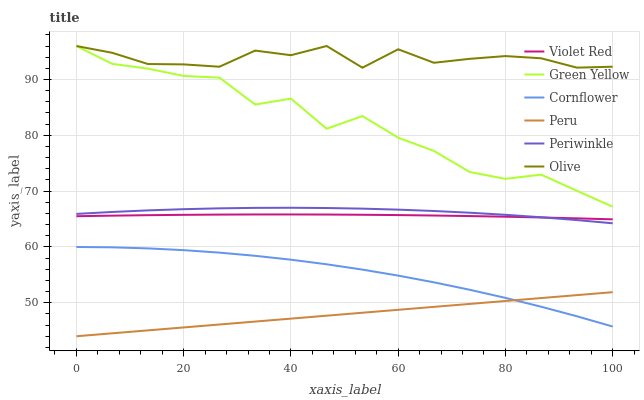Does Peru have the minimum area under the curve?
Answer yes or no. Yes. Does Olive have the maximum area under the curve?
Answer yes or no. Yes. Does Violet Red have the minimum area under the curve?
Answer yes or no. No. Does Violet Red have the maximum area under the curve?
Answer yes or no. No. Is Peru the smoothest?
Answer yes or no. Yes. Is Green Yellow the roughest?
Answer yes or no. Yes. Is Violet Red the smoothest?
Answer yes or no. No. Is Violet Red the roughest?
Answer yes or no. No. Does Peru have the lowest value?
Answer yes or no. Yes. Does Violet Red have the lowest value?
Answer yes or no. No. Does Green Yellow have the highest value?
Answer yes or no. Yes. Does Violet Red have the highest value?
Answer yes or no. No. Is Peru less than Olive?
Answer yes or no. Yes. Is Olive greater than Periwinkle?
Answer yes or no. Yes. Does Cornflower intersect Peru?
Answer yes or no. Yes. Is Cornflower less than Peru?
Answer yes or no. No. Is Cornflower greater than Peru?
Answer yes or no. No. Does Peru intersect Olive?
Answer yes or no. No. 